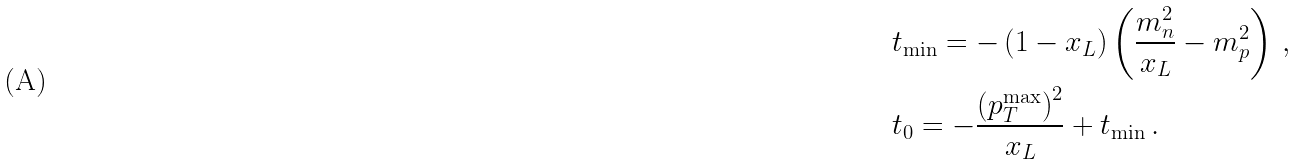<formula> <loc_0><loc_0><loc_500><loc_500>& { t _ { \min } } = - \left ( { 1 - { x _ { L } } } \right ) \left ( { \frac { m _ { n } ^ { 2 } } { x _ { L } } - m _ { p } ^ { 2 } } \right ) \, , \\ & { t _ { 0 } } = - \frac { { { { \left ( { p _ { T } ^ { \max } } \right ) } ^ { 2 } } } } { x _ { L } } + { t _ { \min } } \, .</formula> 